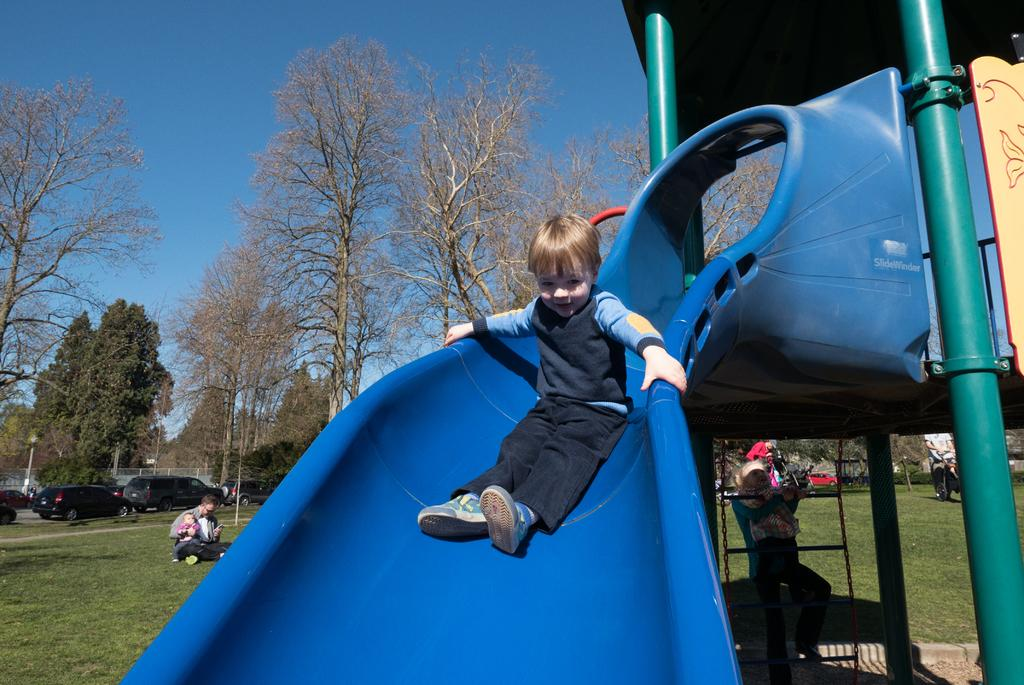What is the kid doing in the image? The kid is on a slide in the image. Can you describe the people in the image? There are people in the image, but their specific actions or roles are not mentioned in the facts. What can be seen in the background of the image? In the background of the image, there are cars, trees, and the sky visible. What type of surface is the slide on? The grass in the image suggests that the slide is on a grassy surface. What is the purpose of the fence in the image? The purpose of the fence in the image is not mentioned in the facts. What type of tray is being used by the police to crush the kid on the slide in the image? There is no mention of a tray, police, or the kid being crushed in the image. The image only shows a kid on a slide, people, cars, trees, the sky, grass, and a fence. 